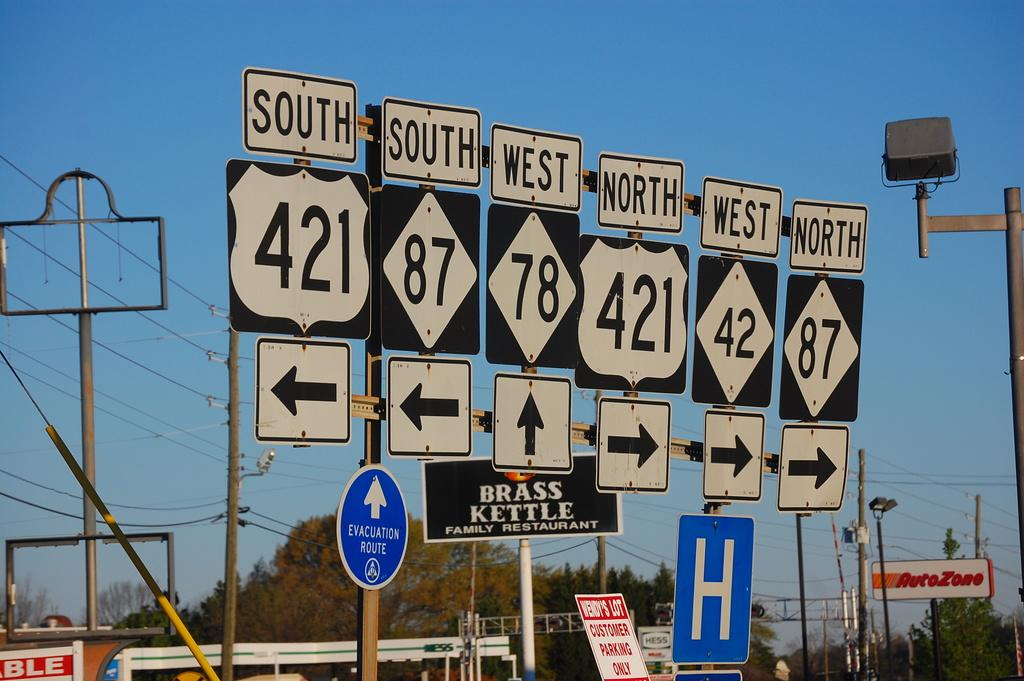Provide a one-sentence caption for the provided image. Several interstate signs with different numbers and arrows are lined up, in a row near several businesses like the Brass Kettle. 